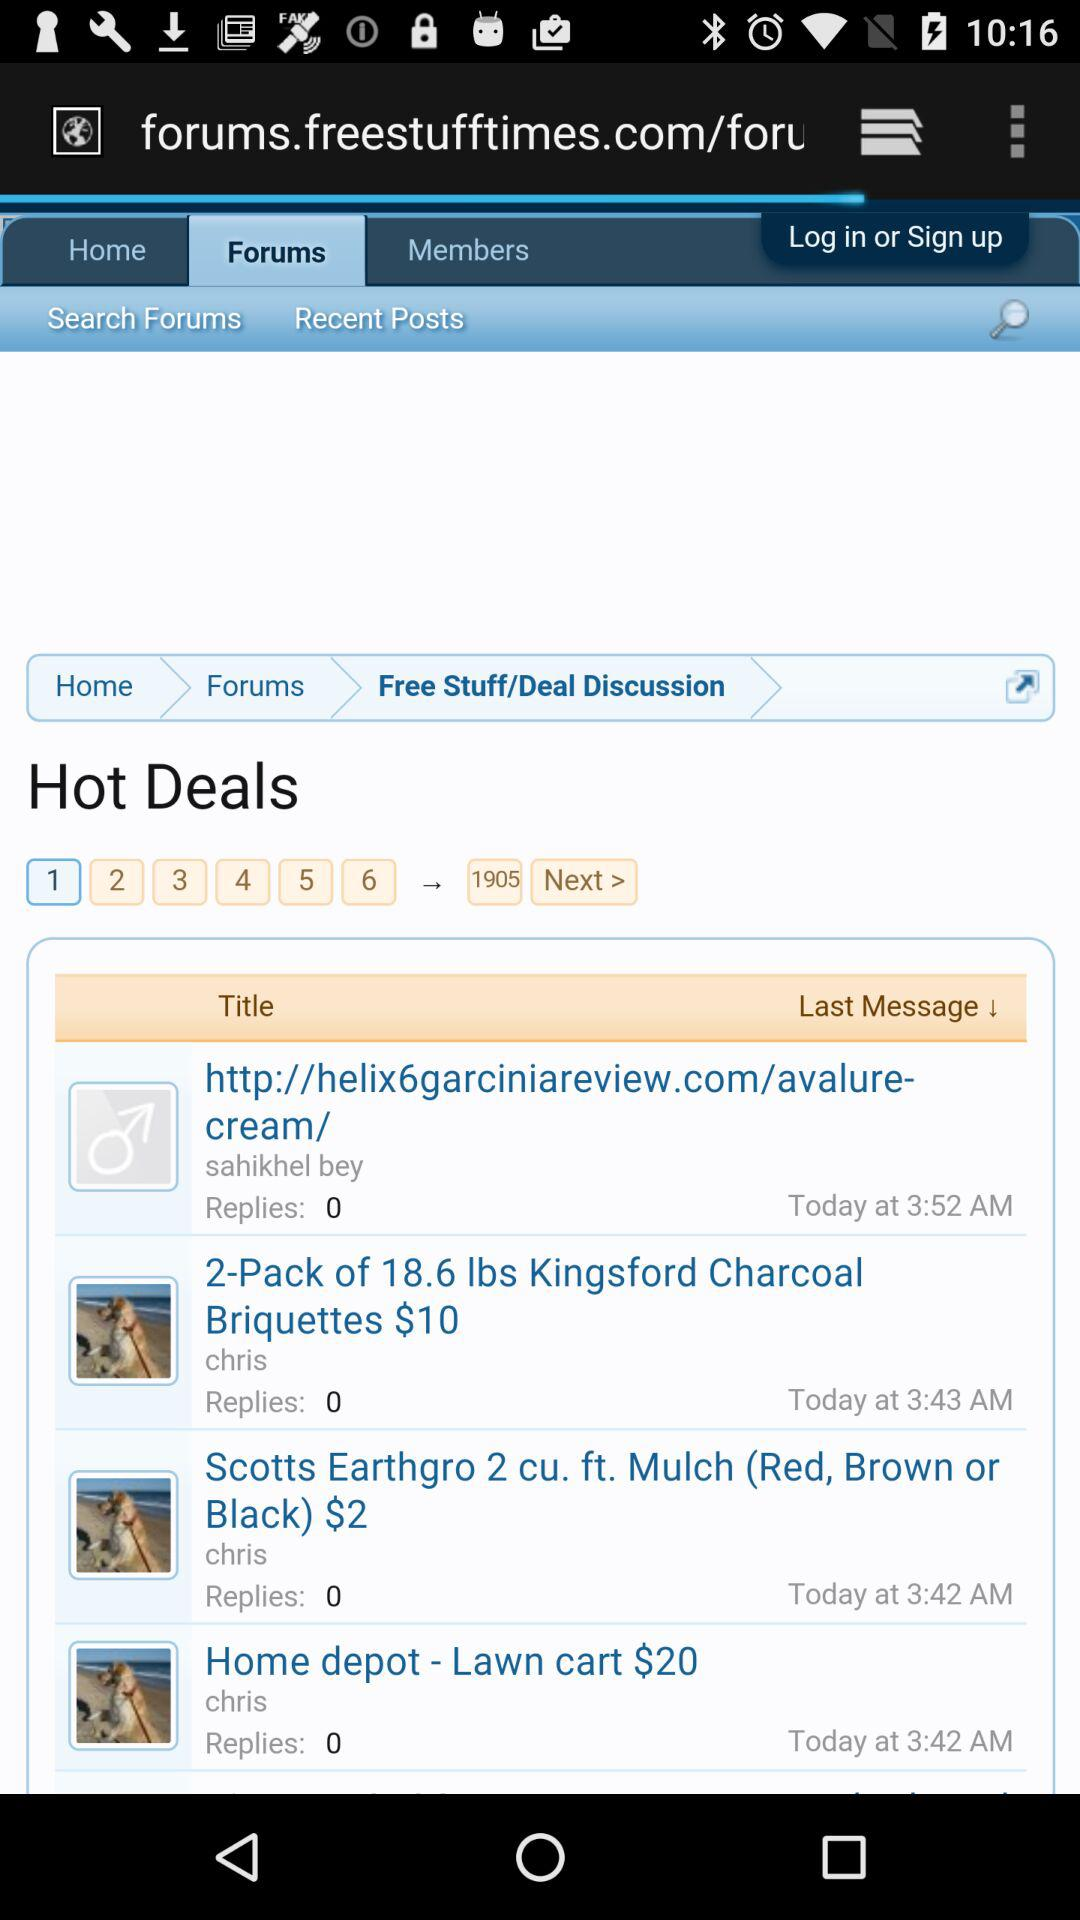How many replies are there for the deal posted by Sahikhel Bey? There are 0 replies for the deal posted by Sahikhel Bey. 